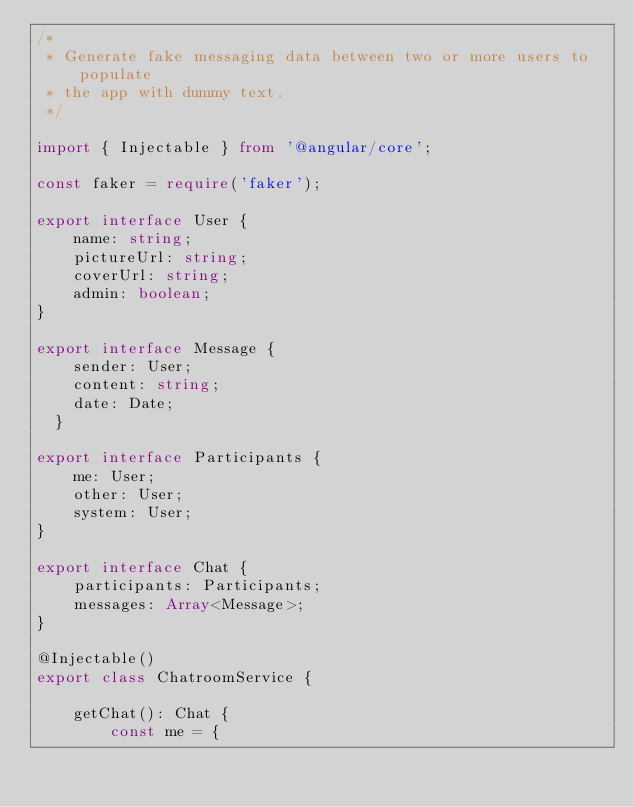<code> <loc_0><loc_0><loc_500><loc_500><_TypeScript_>/*
 * Generate fake messaging data between two or more users to populate
 * the app with dummy text.
 */

import { Injectable } from '@angular/core';

const faker = require('faker');

export interface User {
    name: string;
    pictureUrl: string;
    coverUrl: string;
    admin: boolean;
}

export interface Message {
    sender: User;
    content: string;
    date: Date;
  }

export interface Participants {
    me: User;
    other: User;
    system: User;
}

export interface Chat {
    participants: Participants;
    messages: Array<Message>;
}

@Injectable()
export class ChatroomService {

    getChat(): Chat {
        const me = {</code> 